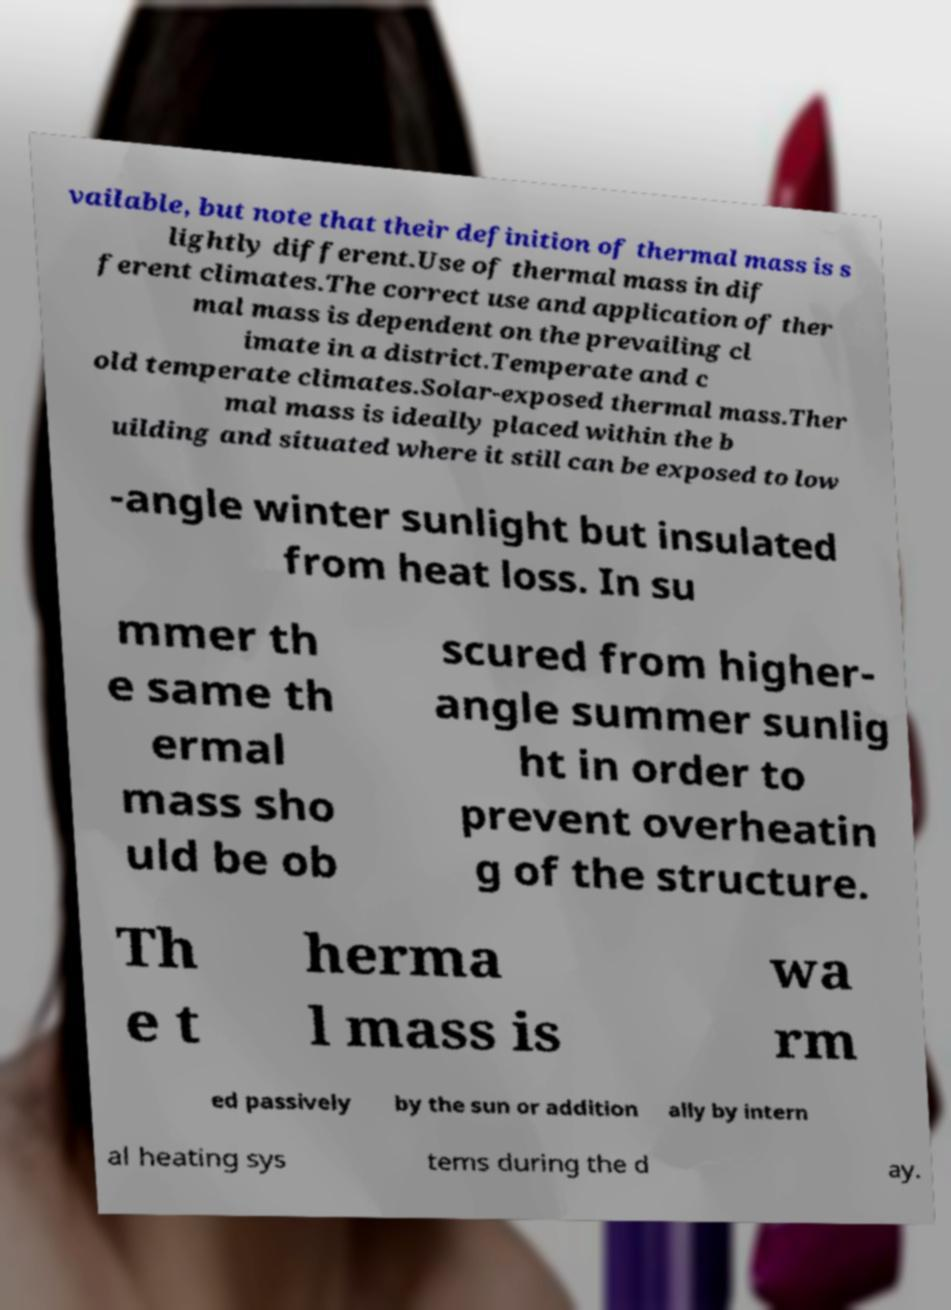Can you accurately transcribe the text from the provided image for me? vailable, but note that their definition of thermal mass is s lightly different.Use of thermal mass in dif ferent climates.The correct use and application of ther mal mass is dependent on the prevailing cl imate in a district.Temperate and c old temperate climates.Solar-exposed thermal mass.Ther mal mass is ideally placed within the b uilding and situated where it still can be exposed to low -angle winter sunlight but insulated from heat loss. In su mmer th e same th ermal mass sho uld be ob scured from higher- angle summer sunlig ht in order to prevent overheatin g of the structure. Th e t herma l mass is wa rm ed passively by the sun or addition ally by intern al heating sys tems during the d ay. 